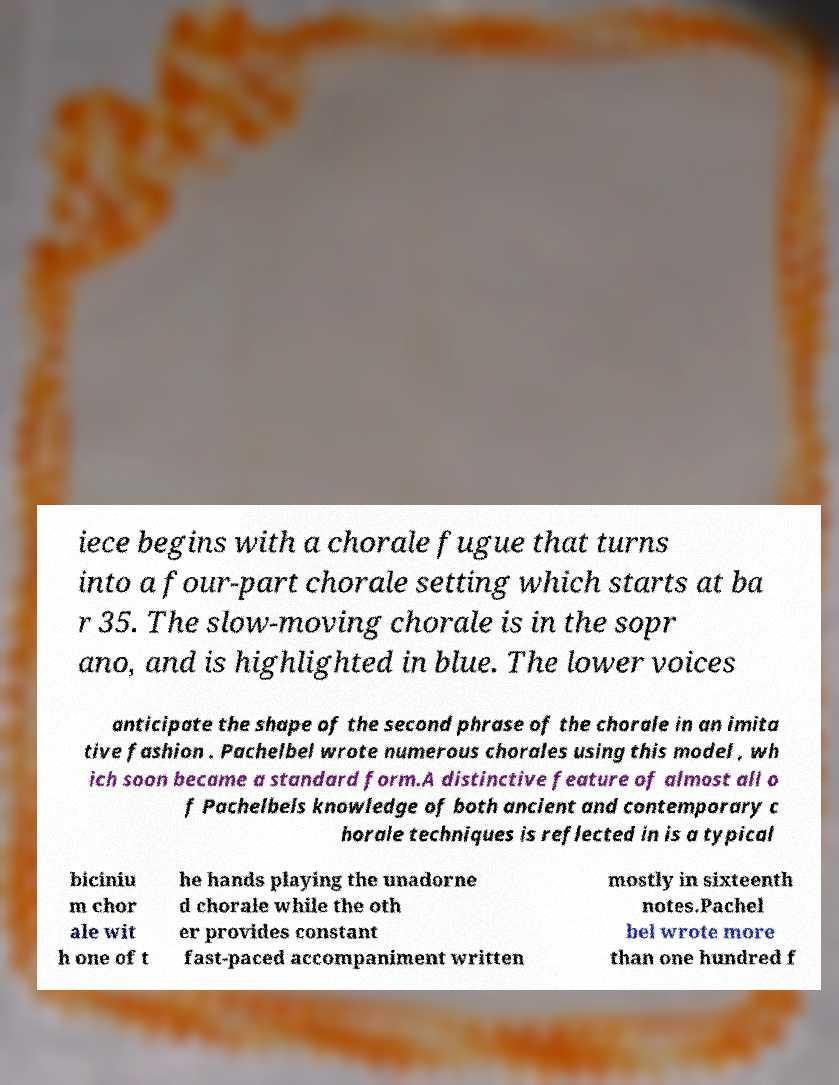Please read and relay the text visible in this image. What does it say? iece begins with a chorale fugue that turns into a four-part chorale setting which starts at ba r 35. The slow-moving chorale is in the sopr ano, and is highlighted in blue. The lower voices anticipate the shape of the second phrase of the chorale in an imita tive fashion . Pachelbel wrote numerous chorales using this model , wh ich soon became a standard form.A distinctive feature of almost all o f Pachelbels knowledge of both ancient and contemporary c horale techniques is reflected in is a typical biciniu m chor ale wit h one of t he hands playing the unadorne d chorale while the oth er provides constant fast-paced accompaniment written mostly in sixteenth notes.Pachel bel wrote more than one hundred f 